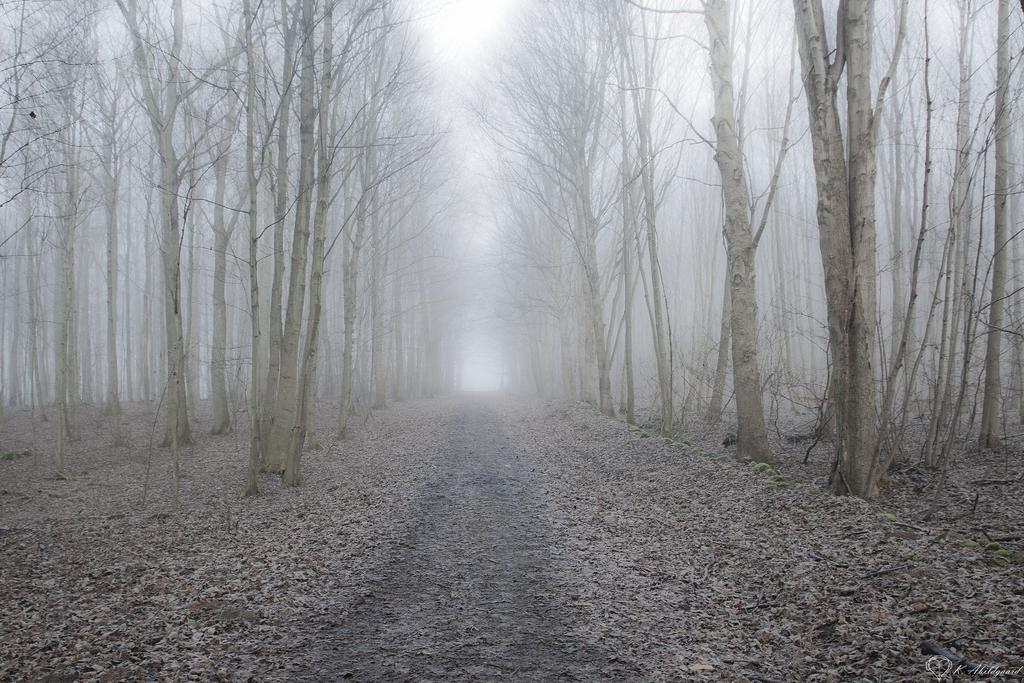Describe this image in one or two sentences. In this image we can see dried leaves on the ground. There are bare trees. In the background there is sky. 